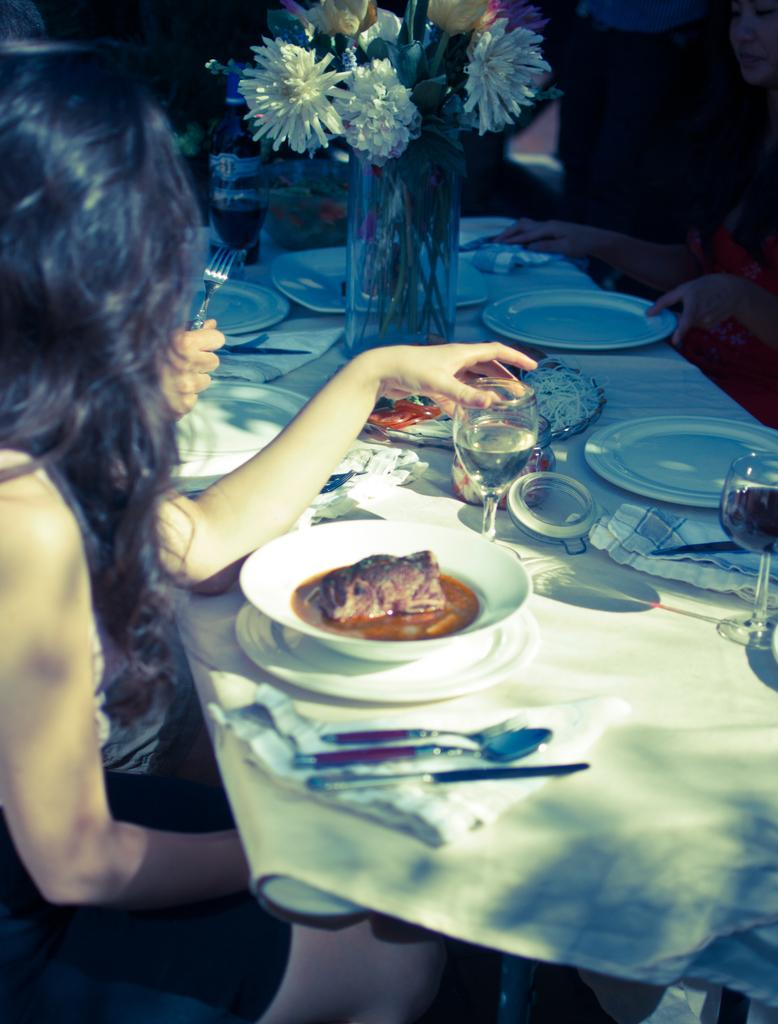Who is present in the image? There is a lady in the image. What is the lady doing in the image? The lady is sitting. What object can be seen in the image besides the lady? There is a table in the image. What is on the table in the image? There are things placed on the table. What type of reward is the lady receiving on the stage in the image? There is no stage or reward present in the image; it only features a lady sitting and a table. 